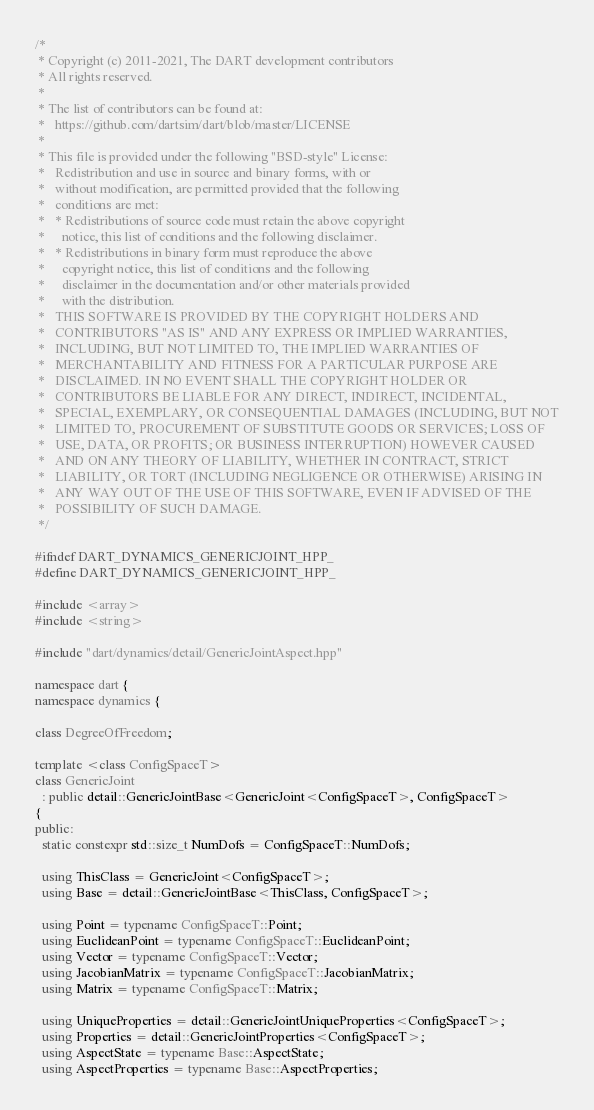<code> <loc_0><loc_0><loc_500><loc_500><_C++_>/*
 * Copyright (c) 2011-2021, The DART development contributors
 * All rights reserved.
 *
 * The list of contributors can be found at:
 *   https://github.com/dartsim/dart/blob/master/LICENSE
 *
 * This file is provided under the following "BSD-style" License:
 *   Redistribution and use in source and binary forms, with or
 *   without modification, are permitted provided that the following
 *   conditions are met:
 *   * Redistributions of source code must retain the above copyright
 *     notice, this list of conditions and the following disclaimer.
 *   * Redistributions in binary form must reproduce the above
 *     copyright notice, this list of conditions and the following
 *     disclaimer in the documentation and/or other materials provided
 *     with the distribution.
 *   THIS SOFTWARE IS PROVIDED BY THE COPYRIGHT HOLDERS AND
 *   CONTRIBUTORS "AS IS" AND ANY EXPRESS OR IMPLIED WARRANTIES,
 *   INCLUDING, BUT NOT LIMITED TO, THE IMPLIED WARRANTIES OF
 *   MERCHANTABILITY AND FITNESS FOR A PARTICULAR PURPOSE ARE
 *   DISCLAIMED. IN NO EVENT SHALL THE COPYRIGHT HOLDER OR
 *   CONTRIBUTORS BE LIABLE FOR ANY DIRECT, INDIRECT, INCIDENTAL,
 *   SPECIAL, EXEMPLARY, OR CONSEQUENTIAL DAMAGES (INCLUDING, BUT NOT
 *   LIMITED TO, PROCUREMENT OF SUBSTITUTE GOODS OR SERVICES; LOSS OF
 *   USE, DATA, OR PROFITS; OR BUSINESS INTERRUPTION) HOWEVER CAUSED
 *   AND ON ANY THEORY OF LIABILITY, WHETHER IN CONTRACT, STRICT
 *   LIABILITY, OR TORT (INCLUDING NEGLIGENCE OR OTHERWISE) ARISING IN
 *   ANY WAY OUT OF THE USE OF THIS SOFTWARE, EVEN IF ADVISED OF THE
 *   POSSIBILITY OF SUCH DAMAGE.
 */

#ifndef DART_DYNAMICS_GENERICJOINT_HPP_
#define DART_DYNAMICS_GENERICJOINT_HPP_

#include <array>
#include <string>

#include "dart/dynamics/detail/GenericJointAspect.hpp"

namespace dart {
namespace dynamics {

class DegreeOfFreedom;

template <class ConfigSpaceT>
class GenericJoint
  : public detail::GenericJointBase<GenericJoint<ConfigSpaceT>, ConfigSpaceT>
{
public:
  static constexpr std::size_t NumDofs = ConfigSpaceT::NumDofs;

  using ThisClass = GenericJoint<ConfigSpaceT>;
  using Base = detail::GenericJointBase<ThisClass, ConfigSpaceT>;

  using Point = typename ConfigSpaceT::Point;
  using EuclideanPoint = typename ConfigSpaceT::EuclideanPoint;
  using Vector = typename ConfigSpaceT::Vector;
  using JacobianMatrix = typename ConfigSpaceT::JacobianMatrix;
  using Matrix = typename ConfigSpaceT::Matrix;

  using UniqueProperties = detail::GenericJointUniqueProperties<ConfigSpaceT>;
  using Properties = detail::GenericJointProperties<ConfigSpaceT>;
  using AspectState = typename Base::AspectState;
  using AspectProperties = typename Base::AspectProperties;
</code> 